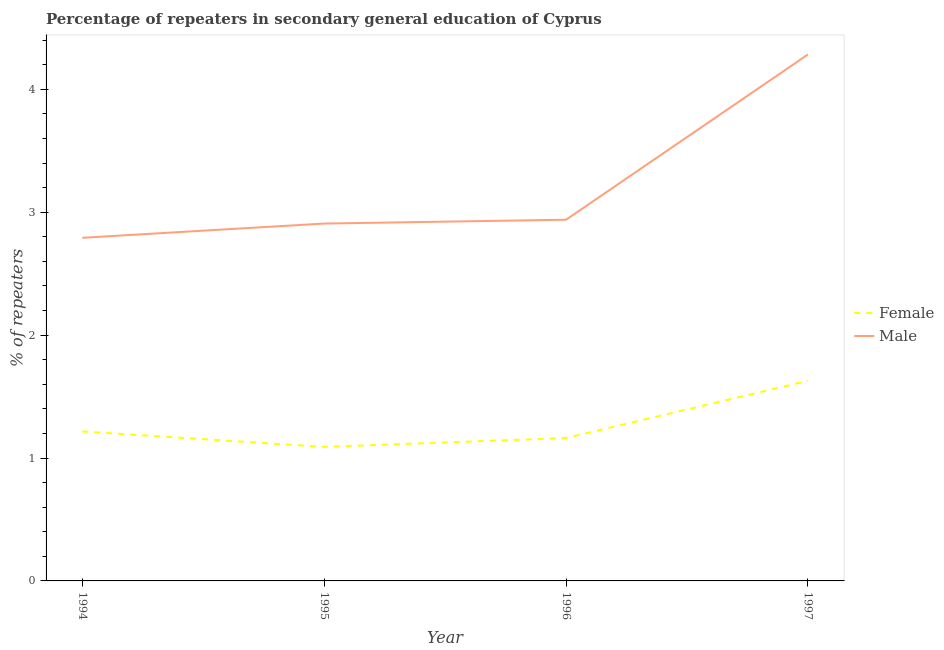How many different coloured lines are there?
Make the answer very short. 2. Is the number of lines equal to the number of legend labels?
Provide a short and direct response. Yes. What is the percentage of male repeaters in 1995?
Your response must be concise. 2.91. Across all years, what is the maximum percentage of female repeaters?
Provide a succinct answer. 1.63. Across all years, what is the minimum percentage of male repeaters?
Provide a short and direct response. 2.79. In which year was the percentage of female repeaters maximum?
Make the answer very short. 1997. What is the total percentage of male repeaters in the graph?
Keep it short and to the point. 12.92. What is the difference between the percentage of female repeaters in 1996 and that in 1997?
Give a very brief answer. -0.47. What is the difference between the percentage of female repeaters in 1994 and the percentage of male repeaters in 1997?
Your answer should be very brief. -3.07. What is the average percentage of male repeaters per year?
Make the answer very short. 3.23. In the year 1995, what is the difference between the percentage of female repeaters and percentage of male repeaters?
Your answer should be very brief. -1.82. What is the ratio of the percentage of male repeaters in 1994 to that in 1995?
Your response must be concise. 0.96. Is the percentage of female repeaters in 1994 less than that in 1996?
Offer a terse response. No. Is the difference between the percentage of male repeaters in 1995 and 1996 greater than the difference between the percentage of female repeaters in 1995 and 1996?
Your response must be concise. Yes. What is the difference between the highest and the second highest percentage of female repeaters?
Your answer should be compact. 0.41. What is the difference between the highest and the lowest percentage of female repeaters?
Your response must be concise. 0.54. In how many years, is the percentage of female repeaters greater than the average percentage of female repeaters taken over all years?
Give a very brief answer. 1. Does the percentage of female repeaters monotonically increase over the years?
Your answer should be compact. No. What is the difference between two consecutive major ticks on the Y-axis?
Your answer should be very brief. 1. Are the values on the major ticks of Y-axis written in scientific E-notation?
Make the answer very short. No. Does the graph contain any zero values?
Provide a succinct answer. No. Where does the legend appear in the graph?
Your answer should be compact. Center right. How are the legend labels stacked?
Your answer should be very brief. Vertical. What is the title of the graph?
Ensure brevity in your answer.  Percentage of repeaters in secondary general education of Cyprus. What is the label or title of the Y-axis?
Offer a terse response. % of repeaters. What is the % of repeaters of Female in 1994?
Provide a succinct answer. 1.22. What is the % of repeaters of Male in 1994?
Your answer should be very brief. 2.79. What is the % of repeaters of Female in 1995?
Your response must be concise. 1.09. What is the % of repeaters in Male in 1995?
Your answer should be very brief. 2.91. What is the % of repeaters in Female in 1996?
Your answer should be very brief. 1.16. What is the % of repeaters in Male in 1996?
Your answer should be compact. 2.94. What is the % of repeaters in Female in 1997?
Ensure brevity in your answer.  1.63. What is the % of repeaters of Male in 1997?
Make the answer very short. 4.28. Across all years, what is the maximum % of repeaters of Female?
Make the answer very short. 1.63. Across all years, what is the maximum % of repeaters in Male?
Your answer should be compact. 4.28. Across all years, what is the minimum % of repeaters of Female?
Keep it short and to the point. 1.09. Across all years, what is the minimum % of repeaters in Male?
Make the answer very short. 2.79. What is the total % of repeaters of Female in the graph?
Provide a succinct answer. 5.1. What is the total % of repeaters in Male in the graph?
Provide a short and direct response. 12.92. What is the difference between the % of repeaters of Female in 1994 and that in 1995?
Offer a terse response. 0.13. What is the difference between the % of repeaters in Male in 1994 and that in 1995?
Your answer should be compact. -0.12. What is the difference between the % of repeaters of Female in 1994 and that in 1996?
Your answer should be very brief. 0.05. What is the difference between the % of repeaters in Male in 1994 and that in 1996?
Ensure brevity in your answer.  -0.15. What is the difference between the % of repeaters in Female in 1994 and that in 1997?
Your response must be concise. -0.41. What is the difference between the % of repeaters of Male in 1994 and that in 1997?
Provide a short and direct response. -1.49. What is the difference between the % of repeaters in Female in 1995 and that in 1996?
Your answer should be compact. -0.07. What is the difference between the % of repeaters of Male in 1995 and that in 1996?
Offer a very short reply. -0.03. What is the difference between the % of repeaters in Female in 1995 and that in 1997?
Offer a very short reply. -0.54. What is the difference between the % of repeaters of Male in 1995 and that in 1997?
Ensure brevity in your answer.  -1.38. What is the difference between the % of repeaters in Female in 1996 and that in 1997?
Your answer should be very brief. -0.47. What is the difference between the % of repeaters of Male in 1996 and that in 1997?
Keep it short and to the point. -1.34. What is the difference between the % of repeaters in Female in 1994 and the % of repeaters in Male in 1995?
Ensure brevity in your answer.  -1.69. What is the difference between the % of repeaters in Female in 1994 and the % of repeaters in Male in 1996?
Provide a succinct answer. -1.72. What is the difference between the % of repeaters of Female in 1994 and the % of repeaters of Male in 1997?
Your answer should be compact. -3.07. What is the difference between the % of repeaters of Female in 1995 and the % of repeaters of Male in 1996?
Provide a short and direct response. -1.85. What is the difference between the % of repeaters of Female in 1995 and the % of repeaters of Male in 1997?
Provide a succinct answer. -3.19. What is the difference between the % of repeaters of Female in 1996 and the % of repeaters of Male in 1997?
Give a very brief answer. -3.12. What is the average % of repeaters in Female per year?
Offer a very short reply. 1.27. What is the average % of repeaters of Male per year?
Ensure brevity in your answer.  3.23. In the year 1994, what is the difference between the % of repeaters of Female and % of repeaters of Male?
Your response must be concise. -1.58. In the year 1995, what is the difference between the % of repeaters in Female and % of repeaters in Male?
Your answer should be compact. -1.82. In the year 1996, what is the difference between the % of repeaters of Female and % of repeaters of Male?
Provide a short and direct response. -1.78. In the year 1997, what is the difference between the % of repeaters in Female and % of repeaters in Male?
Offer a very short reply. -2.65. What is the ratio of the % of repeaters in Female in 1994 to that in 1995?
Ensure brevity in your answer.  1.12. What is the ratio of the % of repeaters of Male in 1994 to that in 1995?
Your answer should be compact. 0.96. What is the ratio of the % of repeaters of Female in 1994 to that in 1996?
Offer a terse response. 1.05. What is the ratio of the % of repeaters in Male in 1994 to that in 1996?
Your answer should be compact. 0.95. What is the ratio of the % of repeaters of Female in 1994 to that in 1997?
Your answer should be compact. 0.75. What is the ratio of the % of repeaters in Male in 1994 to that in 1997?
Offer a very short reply. 0.65. What is the ratio of the % of repeaters of Female in 1995 to that in 1996?
Give a very brief answer. 0.94. What is the ratio of the % of repeaters in Male in 1995 to that in 1996?
Offer a very short reply. 0.99. What is the ratio of the % of repeaters in Female in 1995 to that in 1997?
Offer a very short reply. 0.67. What is the ratio of the % of repeaters of Male in 1995 to that in 1997?
Your answer should be compact. 0.68. What is the ratio of the % of repeaters in Female in 1996 to that in 1997?
Your response must be concise. 0.71. What is the ratio of the % of repeaters in Male in 1996 to that in 1997?
Provide a succinct answer. 0.69. What is the difference between the highest and the second highest % of repeaters in Female?
Your response must be concise. 0.41. What is the difference between the highest and the second highest % of repeaters in Male?
Your answer should be compact. 1.34. What is the difference between the highest and the lowest % of repeaters of Female?
Your response must be concise. 0.54. What is the difference between the highest and the lowest % of repeaters of Male?
Keep it short and to the point. 1.49. 